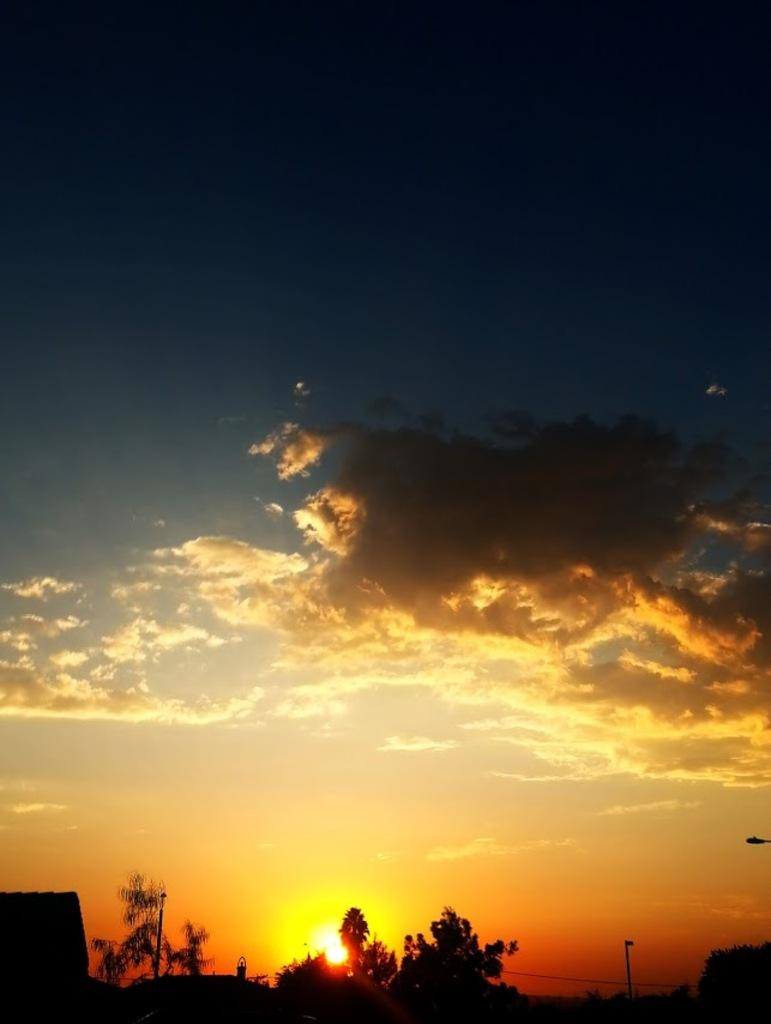What type of structure is visible in the image? There is a house in the image. What other objects can be seen in the image? There are poles, a light, a wire, and trees on the ground visible in the image. Can you describe the sky in the background of the image? The sun is visible in the cloudy sky in the background of the image. What type of plot is being discussed in the image? There is no plot being discussed in the image; it features a house, poles, a light, a wire, trees, and a cloudy sky with the sun visible. Can you see any approval stamps on the house in the image? There are no approval stamps visible on the house in the image. 